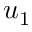<formula> <loc_0><loc_0><loc_500><loc_500>u _ { 1 }</formula> 